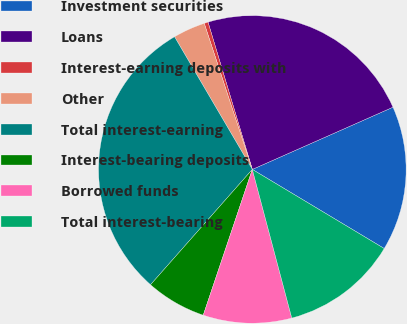<chart> <loc_0><loc_0><loc_500><loc_500><pie_chart><fcel>Investment securities<fcel>Loans<fcel>Interest-earning deposits with<fcel>Other<fcel>Total interest-earning<fcel>Interest-bearing deposits<fcel>Borrowed funds<fcel>Total interest-bearing<nl><fcel>15.23%<fcel>23.02%<fcel>0.41%<fcel>3.38%<fcel>30.05%<fcel>6.34%<fcel>9.3%<fcel>12.27%<nl></chart> 